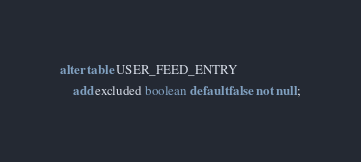<code> <loc_0><loc_0><loc_500><loc_500><_SQL_>alter table USER_FEED_ENTRY
    add excluded boolean default false not null;
</code> 